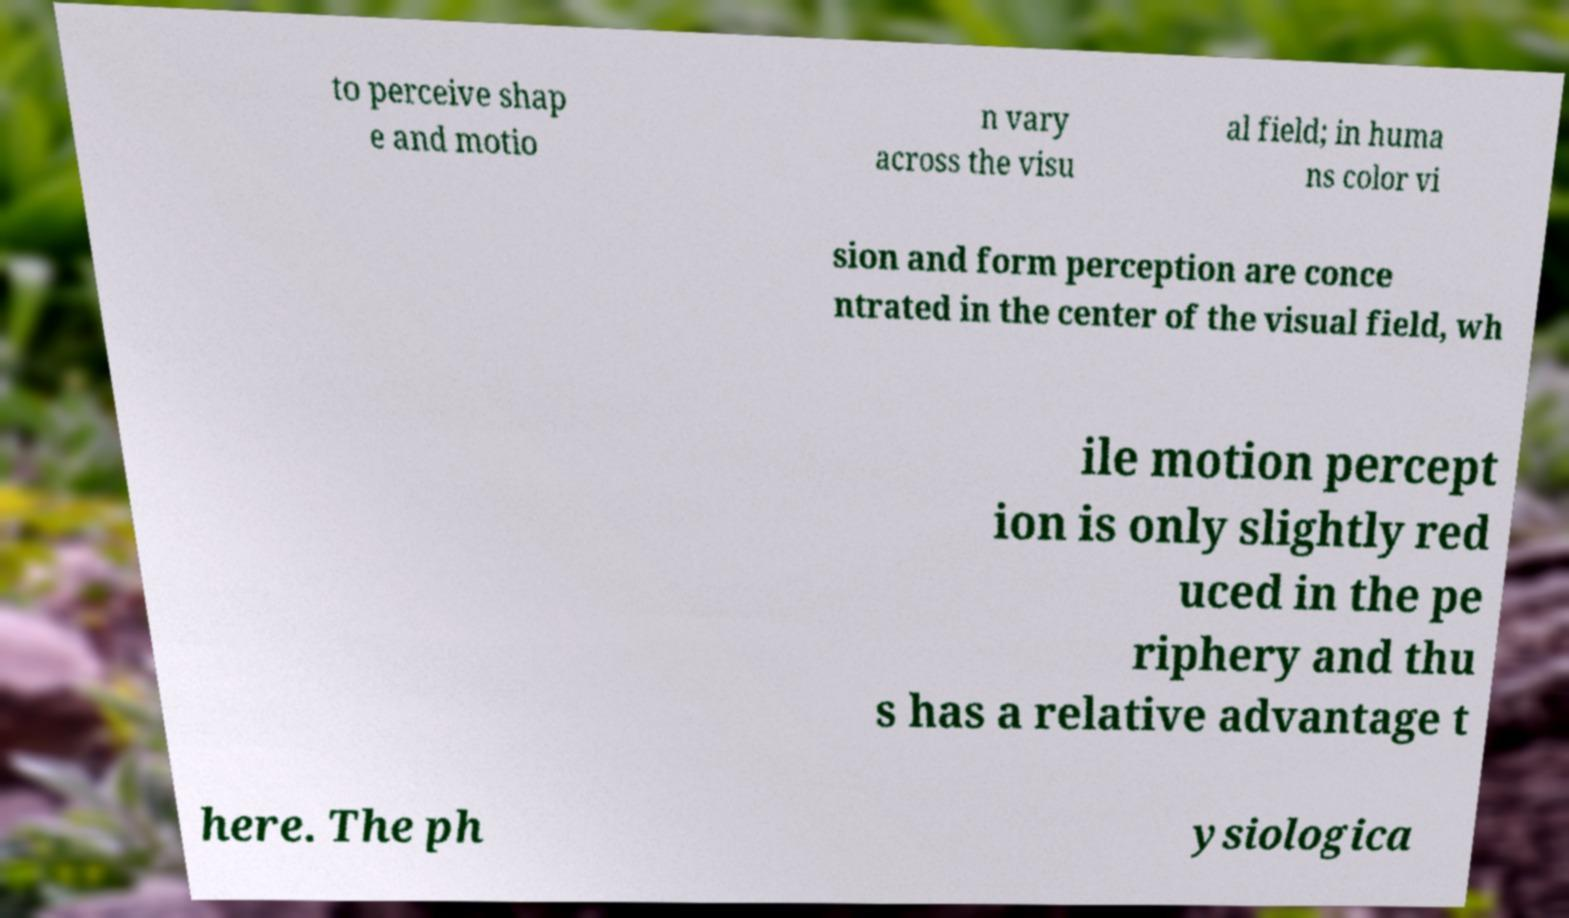Can you accurately transcribe the text from the provided image for me? to perceive shap e and motio n vary across the visu al field; in huma ns color vi sion and form perception are conce ntrated in the center of the visual field, wh ile motion percept ion is only slightly red uced in the pe riphery and thu s has a relative advantage t here. The ph ysiologica 